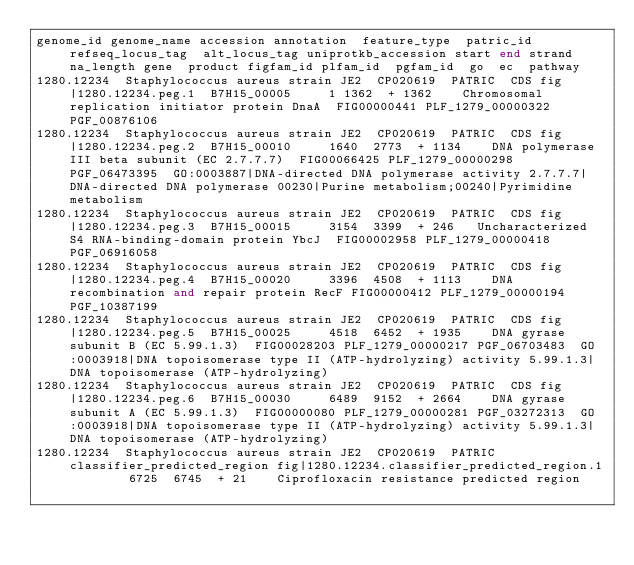<code> <loc_0><loc_0><loc_500><loc_500><_SQL_>genome_id	genome_name	accession	annotation	feature_type	patric_id	refseq_locus_tag	alt_locus_tag	uniprotkb_accession	start	end	strand	na_length	gene	product	figfam_id	plfam_id	pgfam_id	go	ec	pathway
1280.12234	Staphylococcus aureus strain JE2	CP020619	PATRIC	CDS	fig|1280.12234.peg.1	B7H15_00005			1	1362	+	1362		Chromosomal replication initiator protein DnaA	FIG00000441	PLF_1279_00000322	PGF_00876106			
1280.12234	Staphylococcus aureus strain JE2	CP020619	PATRIC	CDS	fig|1280.12234.peg.2	B7H15_00010			1640	2773	+	1134		DNA polymerase III beta subunit (EC 2.7.7.7)	FIG00066425	PLF_1279_00000298	PGF_06473395	GO:0003887|DNA-directed DNA polymerase activity	2.7.7.7|DNA-directed DNA polymerase	00230|Purine metabolism;00240|Pyrimidine metabolism
1280.12234	Staphylococcus aureus strain JE2	CP020619	PATRIC	CDS	fig|1280.12234.peg.3	B7H15_00015			3154	3399	+	246		Uncharacterized S4 RNA-binding-domain protein YbcJ	FIG00002958	PLF_1279_00000418	PGF_06916058			
1280.12234	Staphylococcus aureus strain JE2	CP020619	PATRIC	CDS	fig|1280.12234.peg.4	B7H15_00020			3396	4508	+	1113		DNA recombination and repair protein RecF	FIG00000412	PLF_1279_00000194	PGF_10387199			
1280.12234	Staphylococcus aureus strain JE2	CP020619	PATRIC	CDS	fig|1280.12234.peg.5	B7H15_00025			4518	6452	+	1935		DNA gyrase subunit B (EC 5.99.1.3)	FIG00028203	PLF_1279_00000217	PGF_06703483	GO:0003918|DNA topoisomerase type II (ATP-hydrolyzing) activity	5.99.1.3|DNA topoisomerase (ATP-hydrolyzing)	
1280.12234	Staphylococcus aureus strain JE2	CP020619	PATRIC	CDS	fig|1280.12234.peg.6	B7H15_00030			6489	9152	+	2664		DNA gyrase subunit A (EC 5.99.1.3)	FIG00000080	PLF_1279_00000281	PGF_03272313	GO:0003918|DNA topoisomerase type II (ATP-hydrolyzing) activity	5.99.1.3|DNA topoisomerase (ATP-hydrolyzing)	
1280.12234	Staphylococcus aureus strain JE2	CP020619	PATRIC	classifier_predicted_region	fig|1280.12234.classifier_predicted_region.1				6725	6745	+	21		Ciprofloxacin resistance predicted region						</code> 